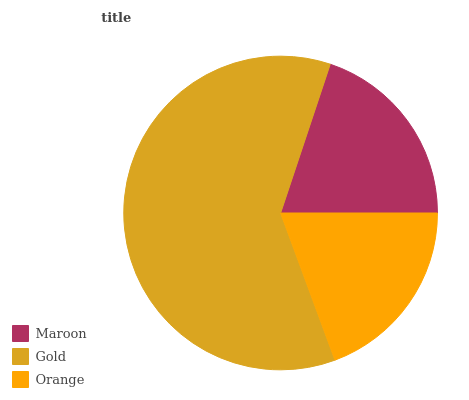Is Orange the minimum?
Answer yes or no. Yes. Is Gold the maximum?
Answer yes or no. Yes. Is Gold the minimum?
Answer yes or no. No. Is Orange the maximum?
Answer yes or no. No. Is Gold greater than Orange?
Answer yes or no. Yes. Is Orange less than Gold?
Answer yes or no. Yes. Is Orange greater than Gold?
Answer yes or no. No. Is Gold less than Orange?
Answer yes or no. No. Is Maroon the high median?
Answer yes or no. Yes. Is Maroon the low median?
Answer yes or no. Yes. Is Orange the high median?
Answer yes or no. No. Is Gold the low median?
Answer yes or no. No. 